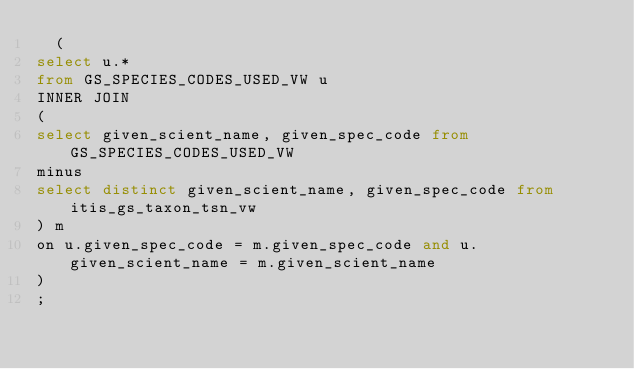<code> <loc_0><loc_0><loc_500><loc_500><_SQL_>  (
select u.* 
from GS_SPECIES_CODES_USED_VW u
INNER JOIN
(
select given_scient_name, given_spec_code from GS_SPECIES_CODES_USED_VW
minus
select distinct given_scient_name, given_spec_code from itis_gs_taxon_tsn_vw
) m
on u.given_spec_code = m.given_spec_code and u.given_scient_name = m.given_scient_name
)
;
</code> 